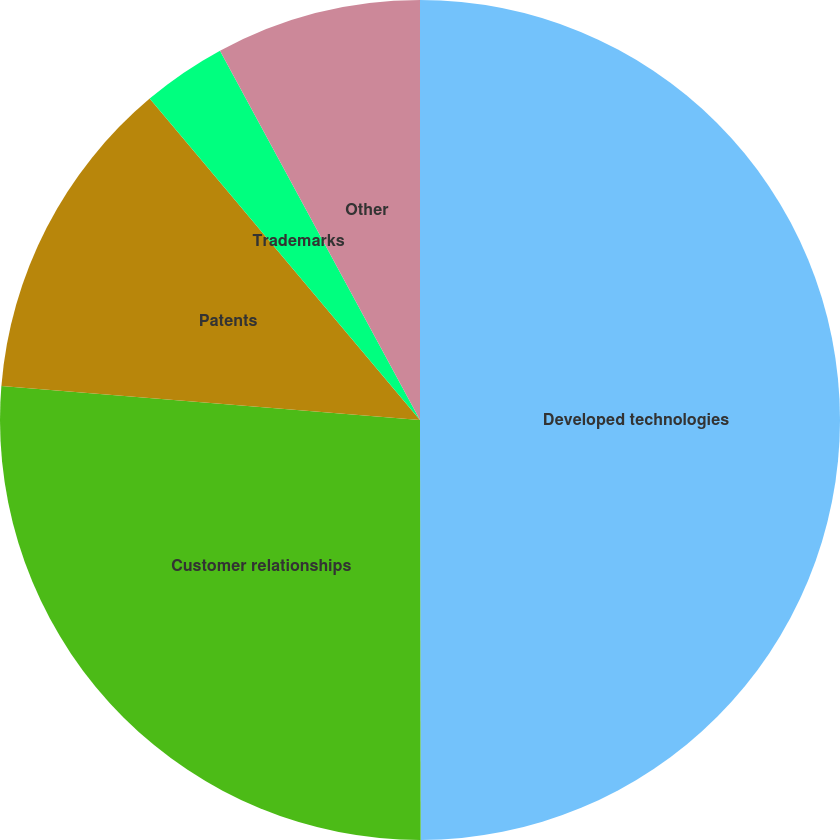Convert chart. <chart><loc_0><loc_0><loc_500><loc_500><pie_chart><fcel>Developed technologies<fcel>Customer relationships<fcel>Patents<fcel>Trademarks<fcel>Other<nl><fcel>49.98%<fcel>26.32%<fcel>12.58%<fcel>3.23%<fcel>7.9%<nl></chart> 